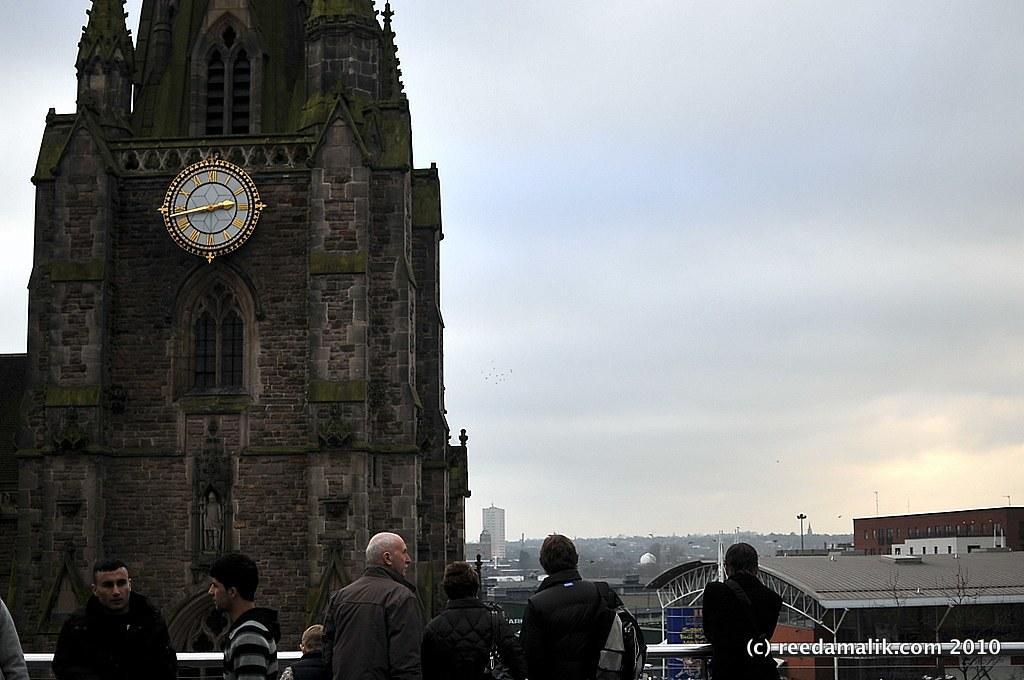In one or two sentences, can you explain what this image depicts? In this image we can see a few people, there are buildings, there is a wall clock, there are poles, also we can see the sky, and the text on the image. 